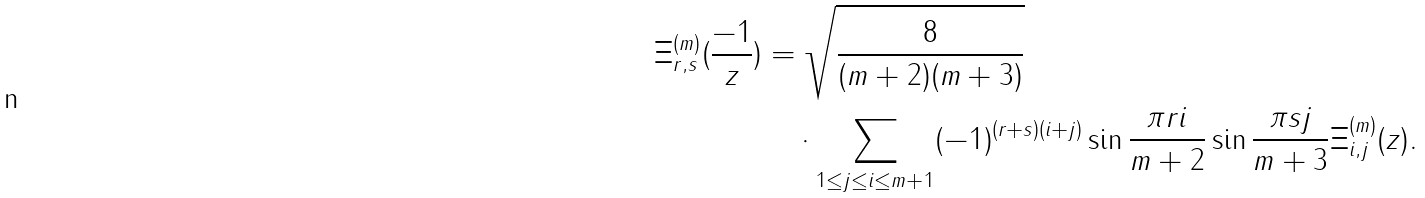<formula> <loc_0><loc_0><loc_500><loc_500>\Xi ^ { ( m ) } _ { r , s } ( \frac { - 1 } { z } ) & = \sqrt { \frac { 8 } { ( m + 2 ) ( m + 3 ) } } \\ & \quad \cdot \sum _ { 1 \leq j \leq i \leq m + 1 } ( - 1 ) ^ { ( r + s ) ( i + j ) } \sin \frac { \pi r i } { m + 2 } \sin \frac { \pi s j } { m + 3 } \Xi ^ { ( m ) } _ { i , j } ( z ) .</formula> 